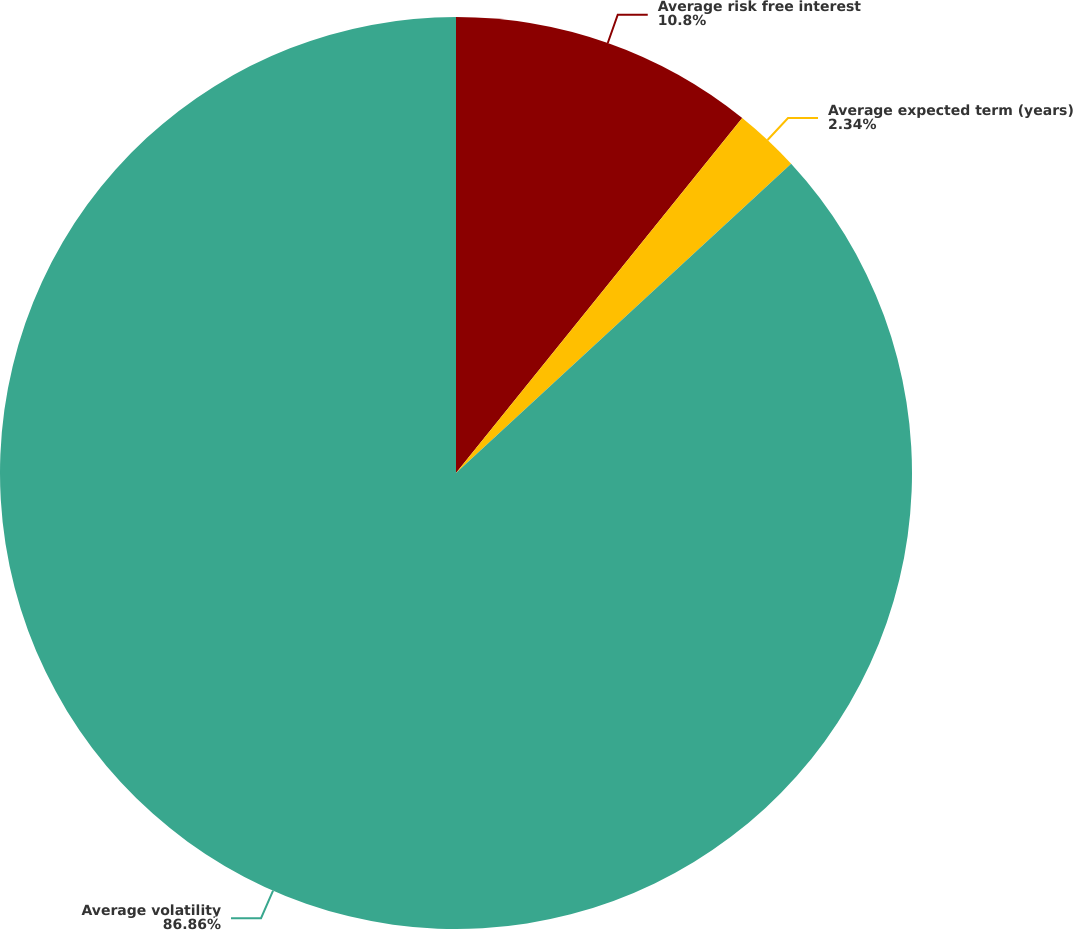Convert chart. <chart><loc_0><loc_0><loc_500><loc_500><pie_chart><fcel>Average risk free interest<fcel>Average expected term (years)<fcel>Average volatility<nl><fcel>10.8%<fcel>2.34%<fcel>86.86%<nl></chart> 